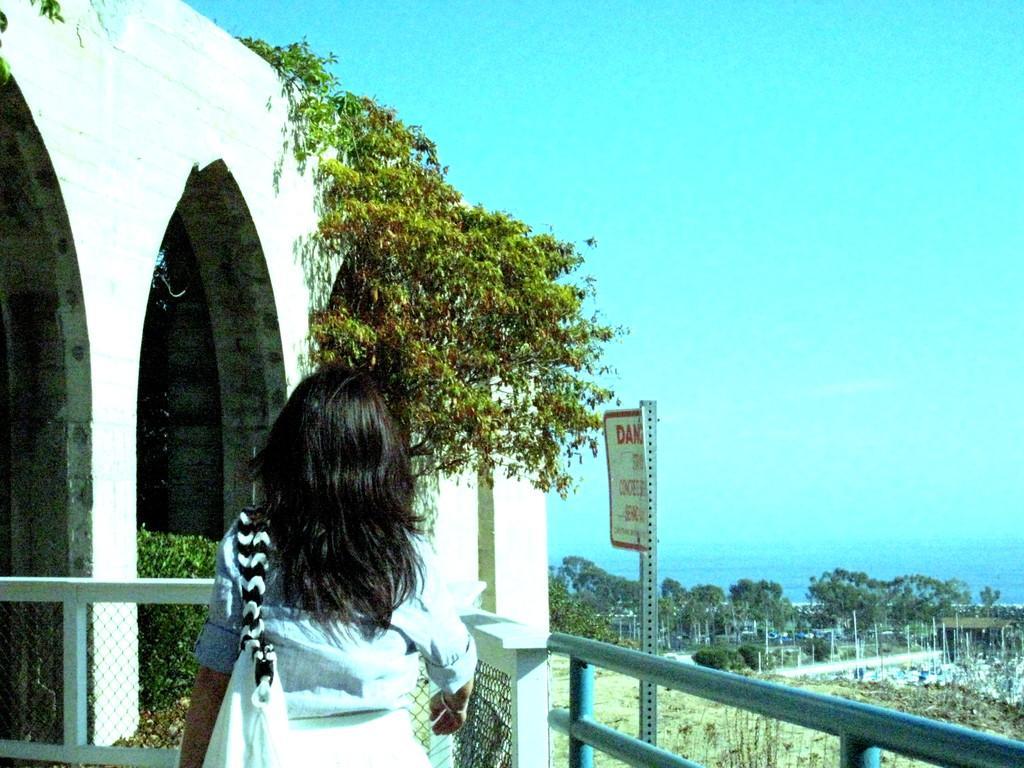Can you describe this image briefly? In this image we can see one building, one fence and one pole with danger board. One woman wearing handbag and walking. There are some objects on the surface, some trees, plants, bushes and grass. At the top there is the sky. 